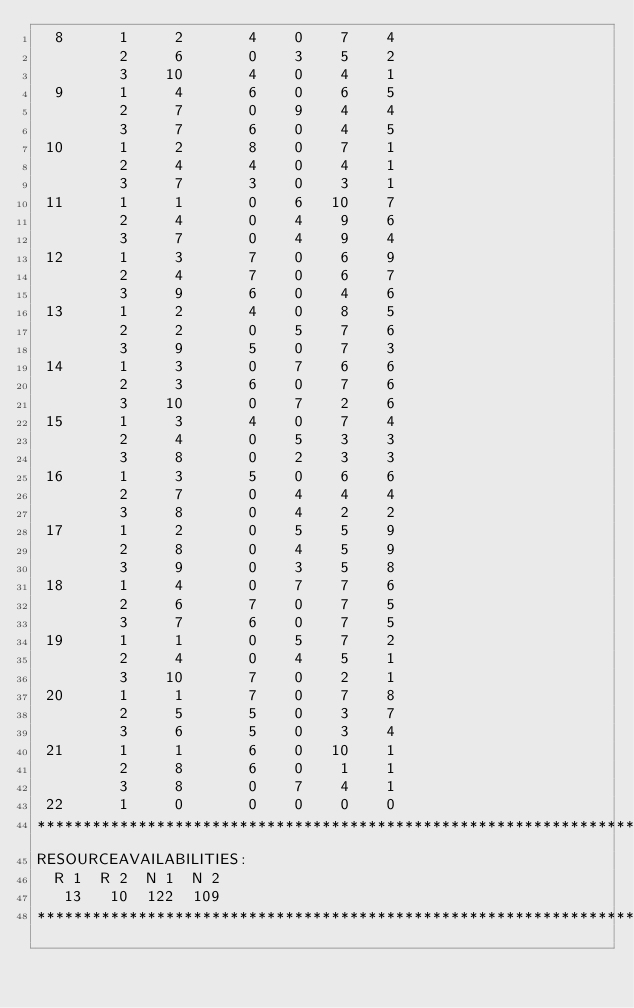Convert code to text. <code><loc_0><loc_0><loc_500><loc_500><_ObjectiveC_>  8      1     2       4    0    7    4
         2     6       0    3    5    2
         3    10       4    0    4    1
  9      1     4       6    0    6    5
         2     7       0    9    4    4
         3     7       6    0    4    5
 10      1     2       8    0    7    1
         2     4       4    0    4    1
         3     7       3    0    3    1
 11      1     1       0    6   10    7
         2     4       0    4    9    6
         3     7       0    4    9    4
 12      1     3       7    0    6    9
         2     4       7    0    6    7
         3     9       6    0    4    6
 13      1     2       4    0    8    5
         2     2       0    5    7    6
         3     9       5    0    7    3
 14      1     3       0    7    6    6
         2     3       6    0    7    6
         3    10       0    7    2    6
 15      1     3       4    0    7    4
         2     4       0    5    3    3
         3     8       0    2    3    3
 16      1     3       5    0    6    6
         2     7       0    4    4    4
         3     8       0    4    2    2
 17      1     2       0    5    5    9
         2     8       0    4    5    9
         3     9       0    3    5    8
 18      1     4       0    7    7    6
         2     6       7    0    7    5
         3     7       6    0    7    5
 19      1     1       0    5    7    2
         2     4       0    4    5    1
         3    10       7    0    2    1
 20      1     1       7    0    7    8
         2     5       5    0    3    7
         3     6       5    0    3    4
 21      1     1       6    0   10    1
         2     8       6    0    1    1
         3     8       0    7    4    1
 22      1     0       0    0    0    0
************************************************************************
RESOURCEAVAILABILITIES:
  R 1  R 2  N 1  N 2
   13   10  122  109
************************************************************************
</code> 